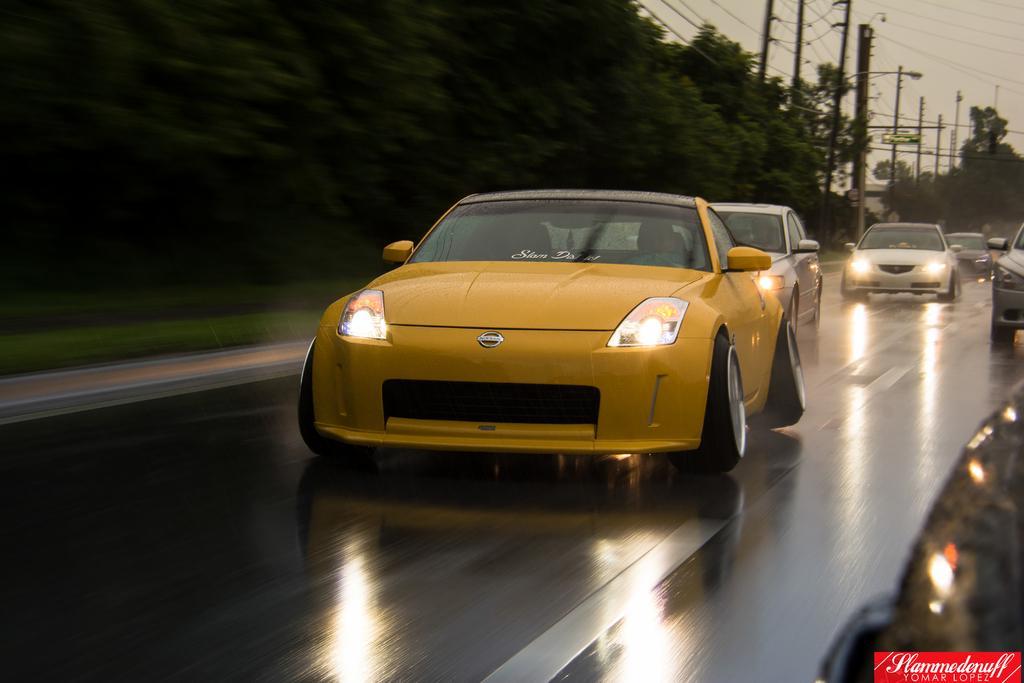Could you give a brief overview of what you see in this image? This image is clicked on the road. There are cars moving on the road. To the left there are trees beside the road. In the background there are street light poles and electric poles. In the top right there is the sky. In the bottom right there is text on the image. 